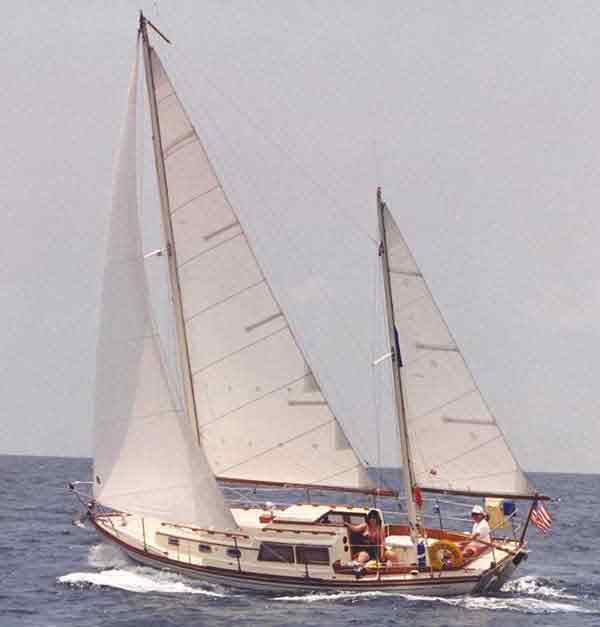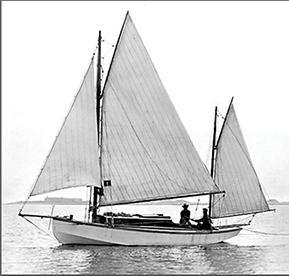The first image is the image on the left, the second image is the image on the right. Assess this claim about the two images: "A hillside at least half the height of the whole image is in the background of a scene with a sailing boat.". Correct or not? Answer yes or no. No. The first image is the image on the left, the second image is the image on the right. Considering the images on both sides, is "One of the images shows a sail with a number on it." valid? Answer yes or no. No. 